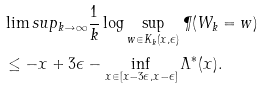<formula> <loc_0><loc_0><loc_500><loc_500>& \lim s u p _ { k \to \infty } \frac { 1 } { k } \log \sup _ { w \in K _ { k } ( x , \epsilon ) } \P ( W _ { k } = w ) \\ & \leq - x + 3 \epsilon - \inf _ { x \in [ x - 3 \epsilon , x - \epsilon ] } \Lambda ^ { * } ( x ) .</formula> 